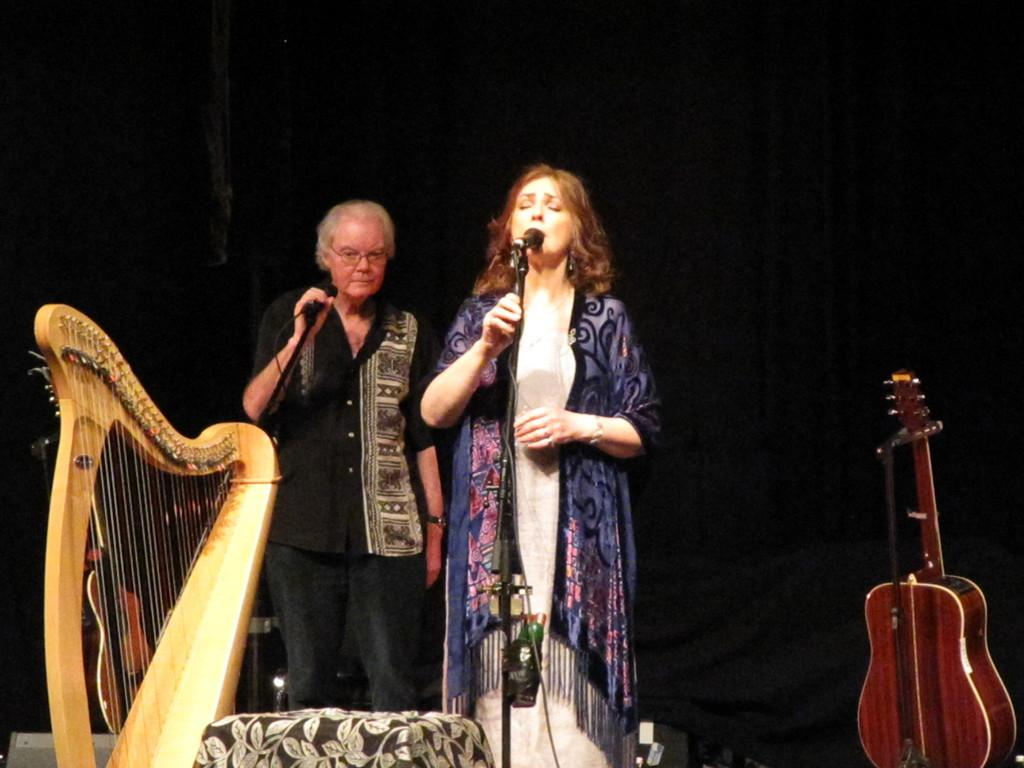How many people are in the image? There are two people in the image. What are the people doing in the image? They are playing musical instruments. Can you describe the position of the microphone in the image? The microphone is in front of a woman. What type of insurance policy is being discussed by the people in the image? There is no indication in the image that the people are discussing insurance policies. 